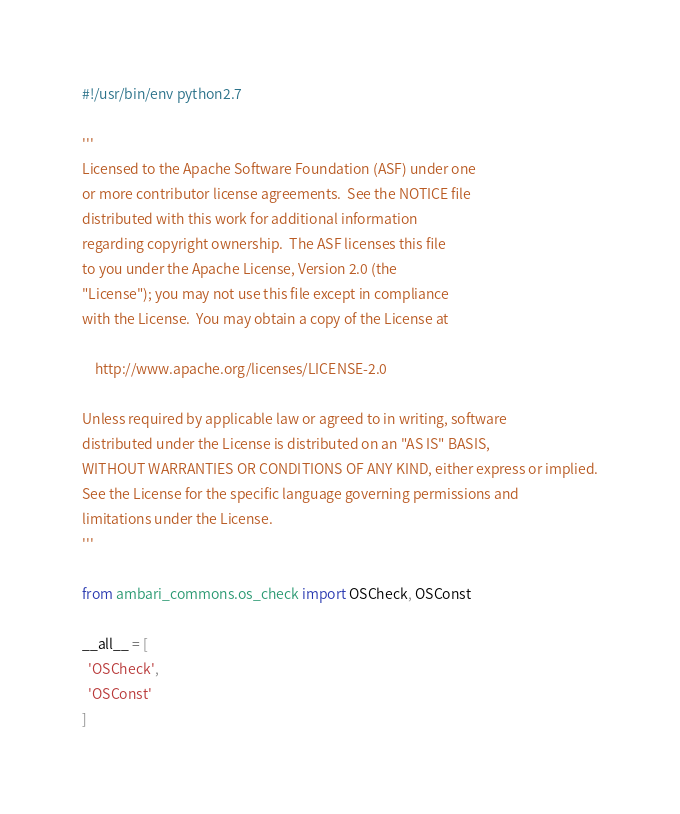Convert code to text. <code><loc_0><loc_0><loc_500><loc_500><_Python_>#!/usr/bin/env python2.7

'''
Licensed to the Apache Software Foundation (ASF) under one
or more contributor license agreements.  See the NOTICE file
distributed with this work for additional information
regarding copyright ownership.  The ASF licenses this file
to you under the Apache License, Version 2.0 (the
"License"); you may not use this file except in compliance
with the License.  You may obtain a copy of the License at

    http://www.apache.org/licenses/LICENSE-2.0

Unless required by applicable law or agreed to in writing, software
distributed under the License is distributed on an "AS IS" BASIS,
WITHOUT WARRANTIES OR CONDITIONS OF ANY KIND, either express or implied.
See the License for the specific language governing permissions and
limitations under the License.
'''

from ambari_commons.os_check import OSCheck, OSConst

__all__ = [
  'OSCheck',
  'OSConst'
]
</code> 